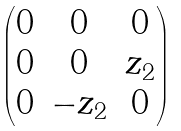Convert formula to latex. <formula><loc_0><loc_0><loc_500><loc_500>\begin{pmatrix} 0 & 0 & 0 \\ 0 & 0 & z _ { 2 } \\ 0 & - z _ { 2 } & 0 \end{pmatrix}</formula> 